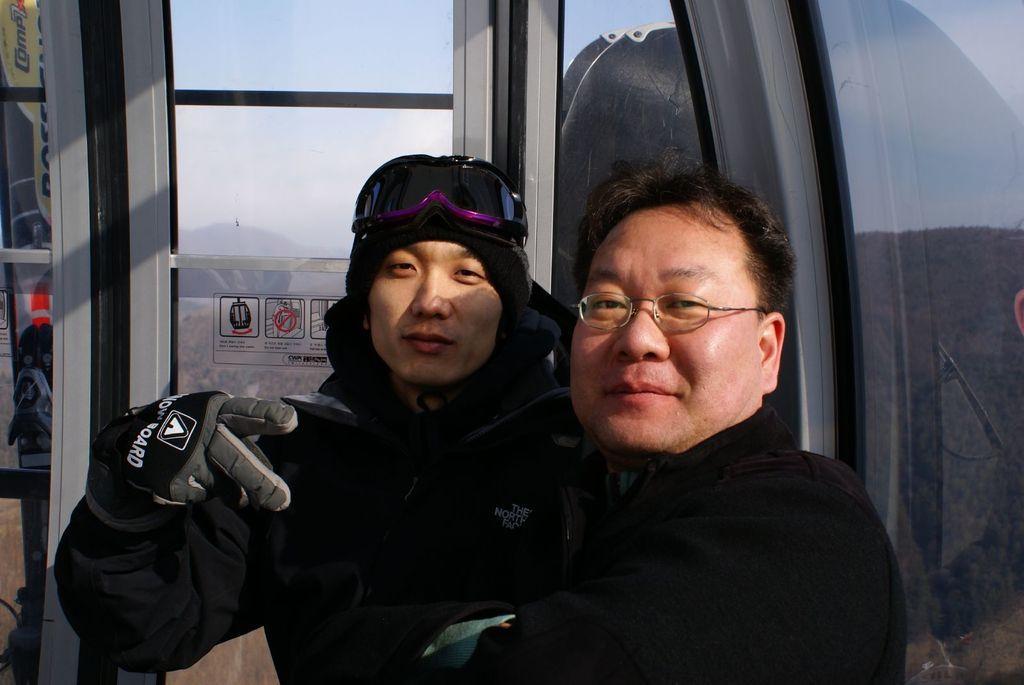In one or two sentences, can you explain what this image depicts? In this picture we can see two men wearing black color jacket smiling and giving a pose into the camera. Behind we can see lift glass door. 